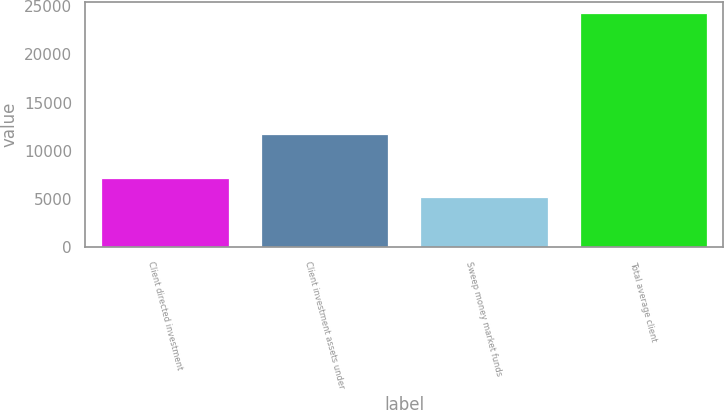Convert chart to OTSL. <chart><loc_0><loc_0><loc_500><loc_500><bar_chart><fcel>Client directed investment<fcel>Client investment assets under<fcel>Sweep money market funds<fcel>Total average client<nl><fcel>7207<fcel>11775<fcel>5237<fcel>24219<nl></chart> 